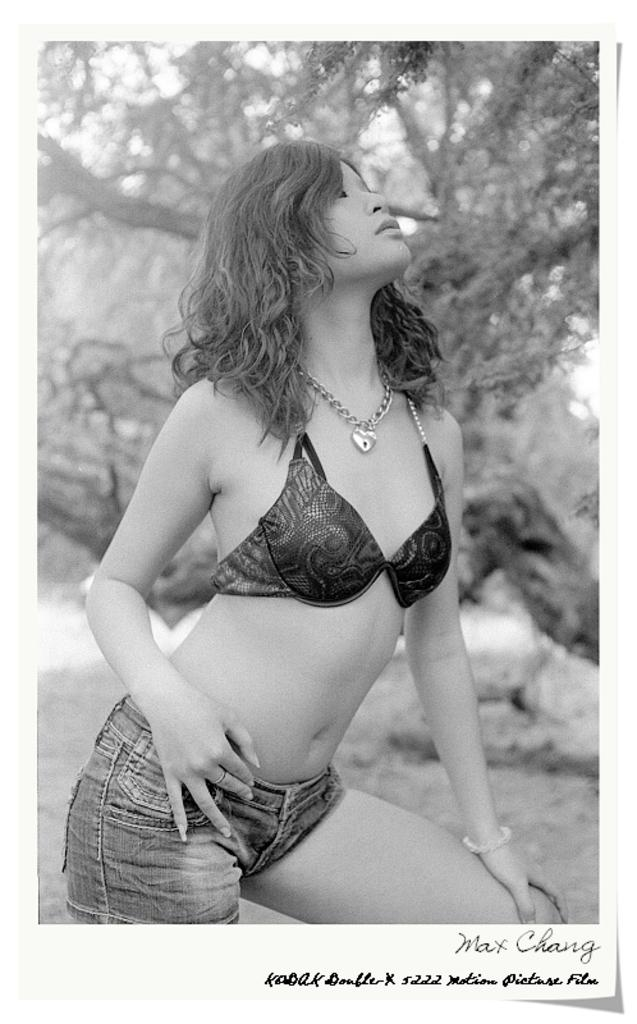Who is the main subject in the image? There is a girl in the center of the image. What can be seen in the background of the image? There are trees in the background of the image. How many chickens are present in the image? There are no chickens present in the image. What is the size of the word "hello" in the image? There is no word "hello" present in the image. 